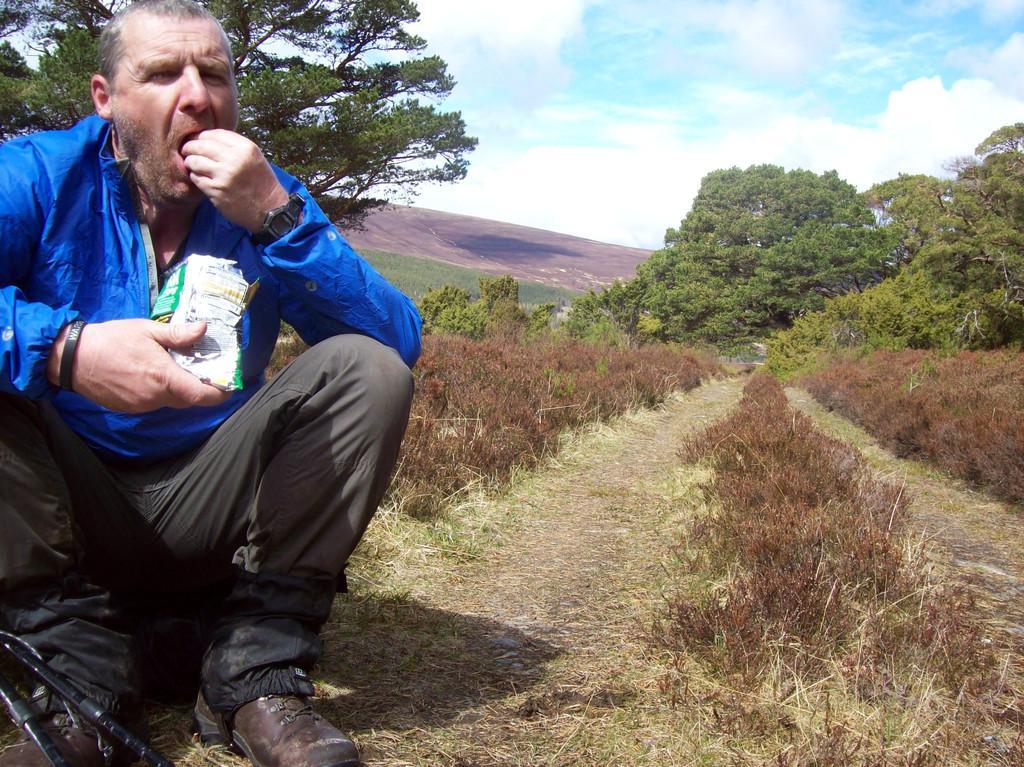In one or two sentences, can you explain what this image depicts? In this image I can see the person sitting and holding some object, the person is wearing blue and gray color dress. In the background I can see few trees in green color and the sky is in blue and white color. 